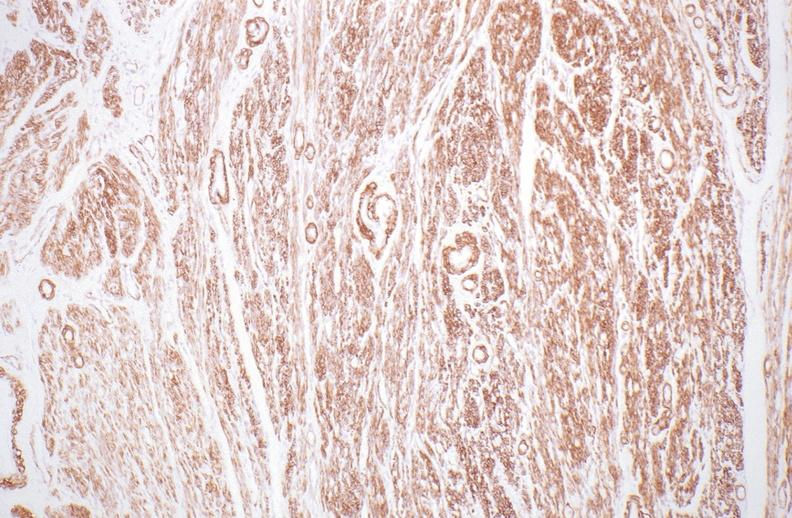what stain?
Answer the question using a single word or phrase. Alpha smooth muscle actin immunohistochemical 